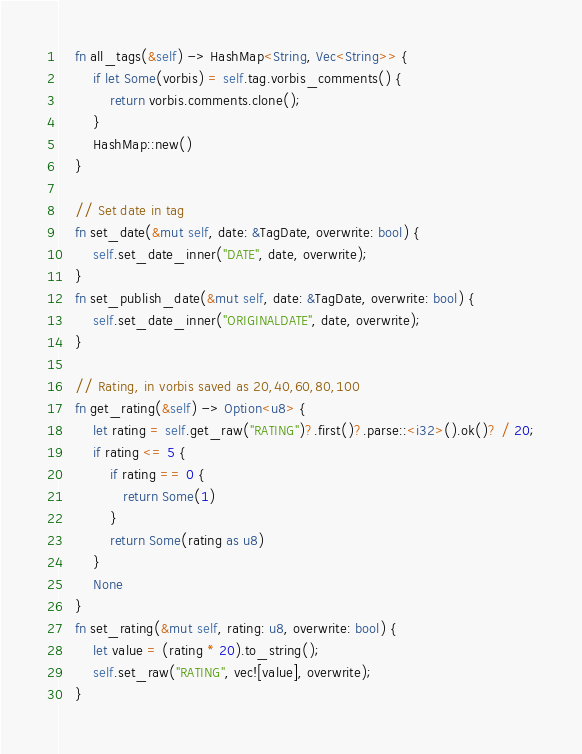Convert code to text. <code><loc_0><loc_0><loc_500><loc_500><_Rust_>    fn all_tags(&self) -> HashMap<String, Vec<String>> {
        if let Some(vorbis) = self.tag.vorbis_comments() {
            return vorbis.comments.clone();
        }
        HashMap::new()
    }

    // Set date in tag
    fn set_date(&mut self, date: &TagDate, overwrite: bool) {
        self.set_date_inner("DATE", date, overwrite);
    }
    fn set_publish_date(&mut self, date: &TagDate, overwrite: bool) {
        self.set_date_inner("ORIGINALDATE", date, overwrite);
    }

    // Rating, in vorbis saved as 20,40,60,80,100
    fn get_rating(&self) -> Option<u8> {
        let rating = self.get_raw("RATING")?.first()?.parse::<i32>().ok()? / 20;
        if rating <= 5 {
            if rating == 0 {
               return Some(1)
            }
            return Some(rating as u8)
        }
        None
    }
    fn set_rating(&mut self, rating: u8, overwrite: bool) {
        let value = (rating * 20).to_string();
        self.set_raw("RATING", vec![value], overwrite);
    }
</code> 